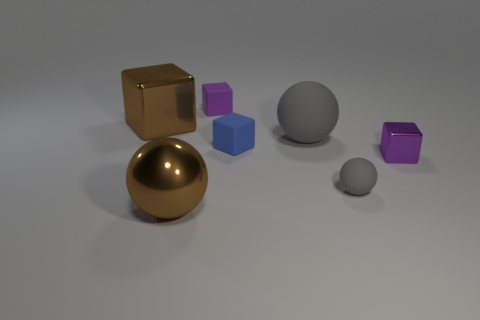Add 2 tiny gray balls. How many objects exist? 9 Subtract all cubes. How many objects are left? 3 Add 1 gray things. How many gray things exist? 3 Subtract 0 green blocks. How many objects are left? 7 Subtract all purple metallic things. Subtract all yellow metal things. How many objects are left? 6 Add 1 gray spheres. How many gray spheres are left? 3 